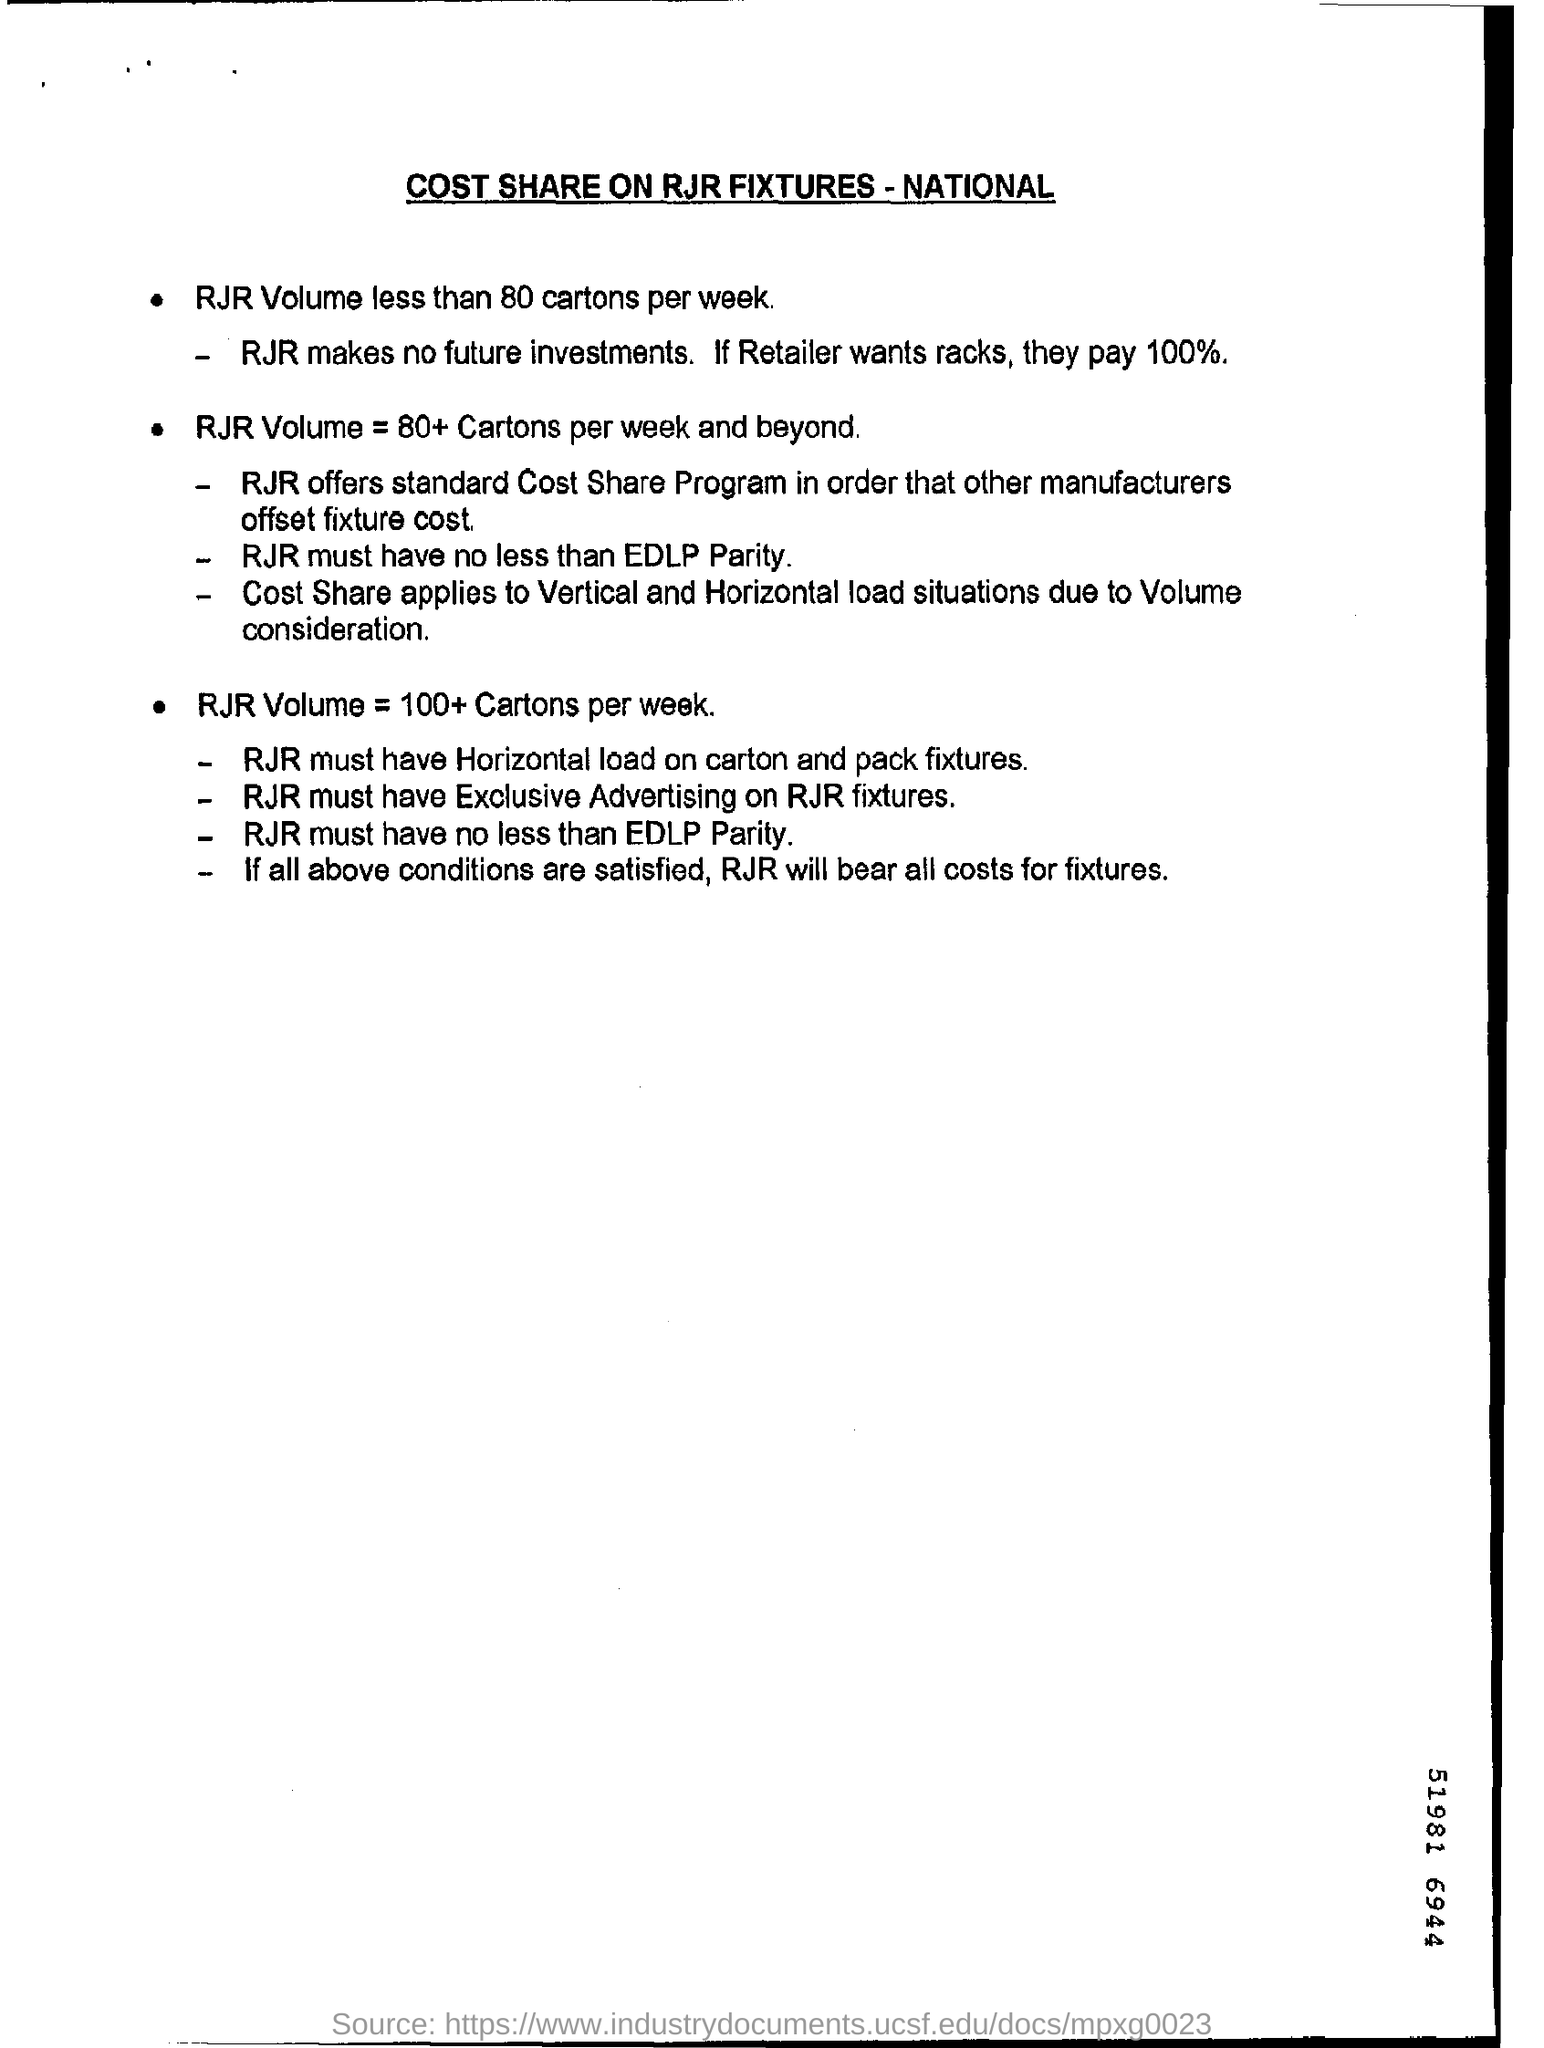Outline some significant characteristics in this image. The retailer should pay 100% for the racks if they want them. This document pertains to a cost share agreement regarding RJR fixtures and is titled 'COST SHARE ON RJR FIXTURES - NATIONAL.' 